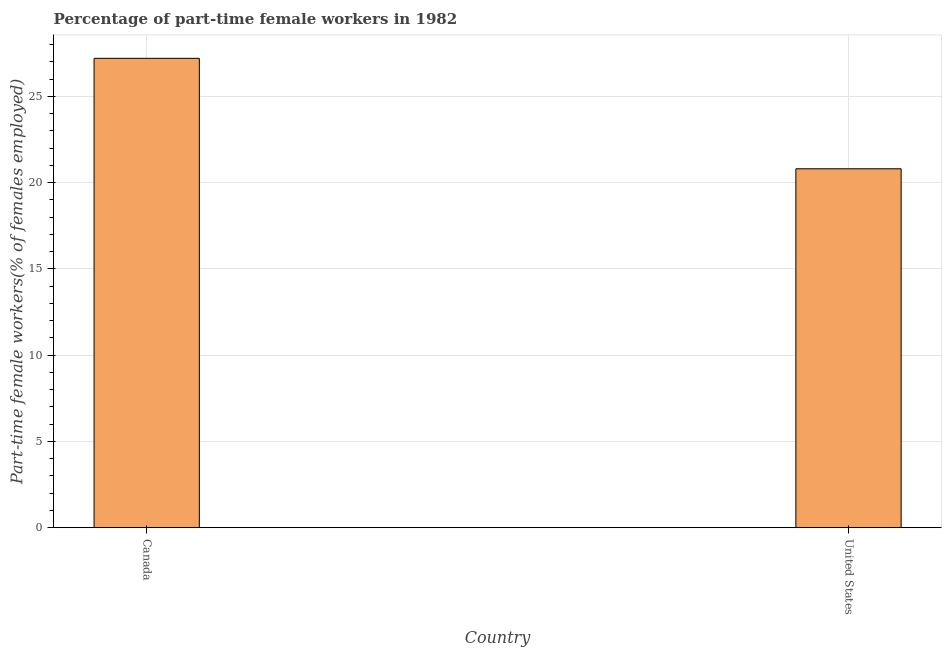Does the graph contain any zero values?
Keep it short and to the point. No. Does the graph contain grids?
Give a very brief answer. Yes. What is the title of the graph?
Provide a succinct answer. Percentage of part-time female workers in 1982. What is the label or title of the Y-axis?
Your answer should be very brief. Part-time female workers(% of females employed). What is the percentage of part-time female workers in United States?
Make the answer very short. 20.8. Across all countries, what is the maximum percentage of part-time female workers?
Give a very brief answer. 27.2. Across all countries, what is the minimum percentage of part-time female workers?
Your answer should be very brief. 20.8. In which country was the percentage of part-time female workers maximum?
Your response must be concise. Canada. In which country was the percentage of part-time female workers minimum?
Offer a very short reply. United States. What is the sum of the percentage of part-time female workers?
Give a very brief answer. 48. What is the average percentage of part-time female workers per country?
Provide a succinct answer. 24. What is the median percentage of part-time female workers?
Offer a terse response. 24. What is the ratio of the percentage of part-time female workers in Canada to that in United States?
Your answer should be compact. 1.31. How many bars are there?
Ensure brevity in your answer.  2. How many countries are there in the graph?
Your answer should be compact. 2. What is the difference between two consecutive major ticks on the Y-axis?
Make the answer very short. 5. Are the values on the major ticks of Y-axis written in scientific E-notation?
Offer a very short reply. No. What is the Part-time female workers(% of females employed) in Canada?
Offer a very short reply. 27.2. What is the Part-time female workers(% of females employed) of United States?
Offer a terse response. 20.8. What is the ratio of the Part-time female workers(% of females employed) in Canada to that in United States?
Your response must be concise. 1.31. 